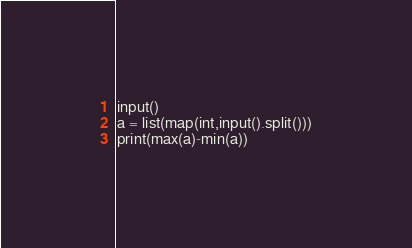<code> <loc_0><loc_0><loc_500><loc_500><_Python_>input()
a = list(map(int,input().split()))
print(max(a)-min(a))</code> 